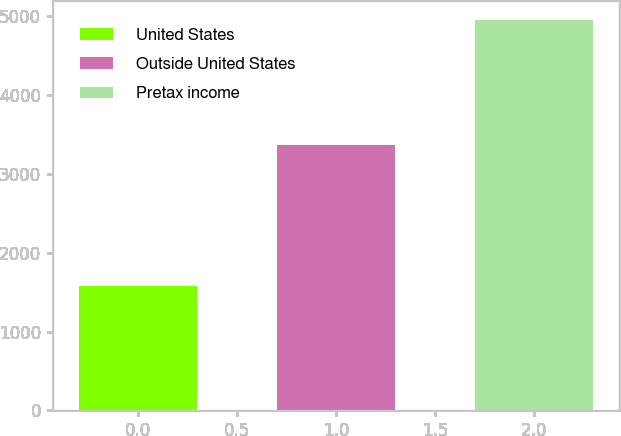Convert chart. <chart><loc_0><loc_0><loc_500><loc_500><bar_chart><fcel>United States<fcel>Outside United States<fcel>Pretax income<nl><fcel>1582<fcel>3366<fcel>4948<nl></chart> 